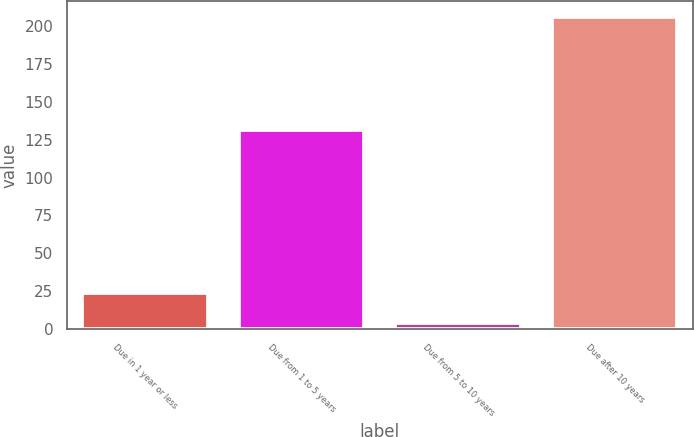Convert chart to OTSL. <chart><loc_0><loc_0><loc_500><loc_500><bar_chart><fcel>Due in 1 year or less<fcel>Due from 1 to 5 years<fcel>Due from 5 to 10 years<fcel>Due after 10 years<nl><fcel>24.2<fcel>131<fcel>4<fcel>206<nl></chart> 